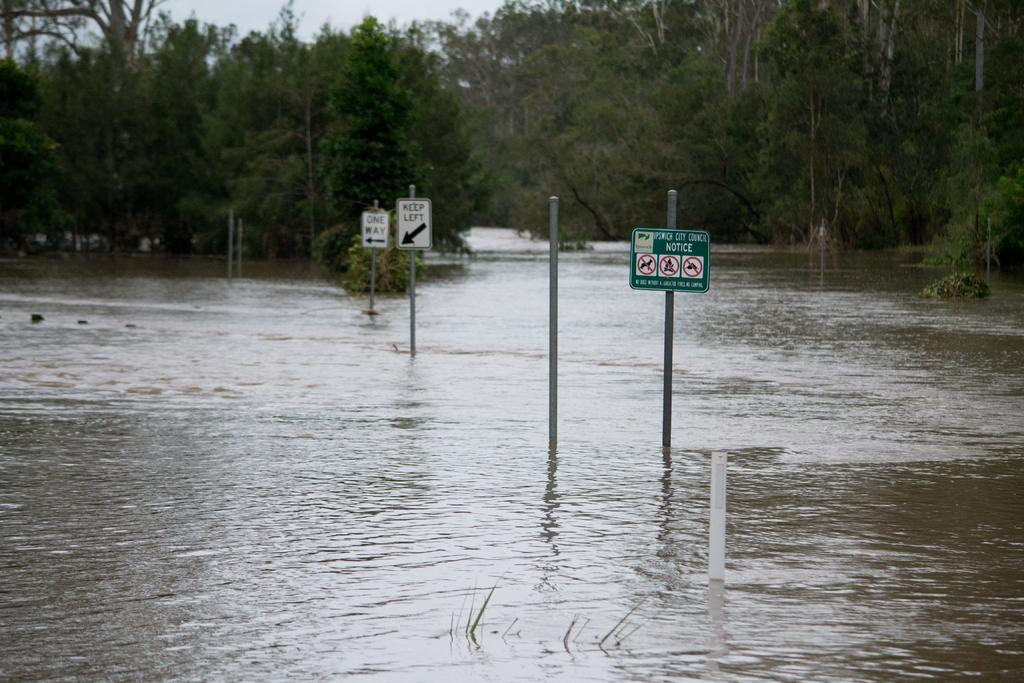What objects are present in the image that are used for support or guidance? There are poles in the image. What objects are floating in the water in the image? There are directional boards in the water. What type of natural scenery can be seen in the background of the image? There are trees in the background of the image. What part of the natural environment is visible in the background of the image? The sky is visible in the background of the image. What type of smoke can be seen coming from the poles in the image? There is no smoke present in the image; it features poles and directional boards in the water. Can you see any swings or feet in the image? There are no swings or feet visible in the image. 